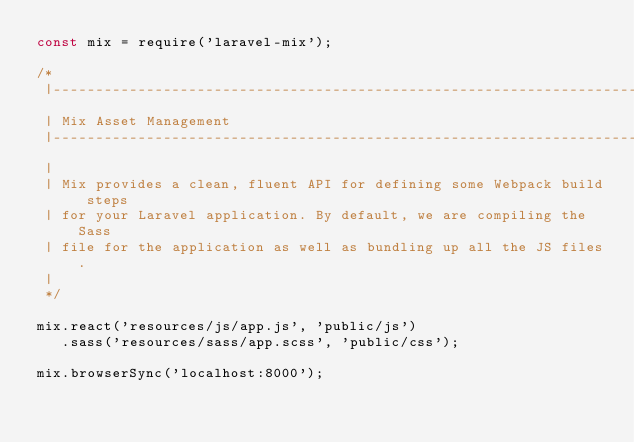Convert code to text. <code><loc_0><loc_0><loc_500><loc_500><_JavaScript_>const mix = require('laravel-mix');

/*
 |--------------------------------------------------------------------------
 | Mix Asset Management
 |--------------------------------------------------------------------------
 |
 | Mix provides a clean, fluent API for defining some Webpack build steps
 | for your Laravel application. By default, we are compiling the Sass
 | file for the application as well as bundling up all the JS files.
 |
 */

mix.react('resources/js/app.js', 'public/js')
   .sass('resources/sass/app.scss', 'public/css');

mix.browserSync('localhost:8000');
</code> 